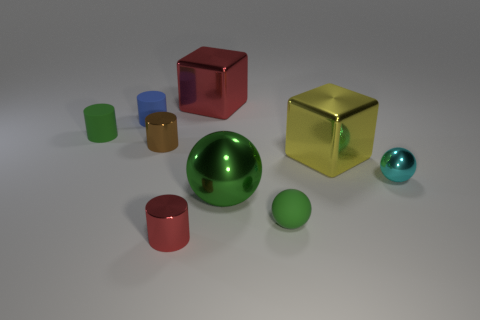Is the rubber sphere the same color as the small metal sphere?
Ensure brevity in your answer.  No. What number of spheres are small brown things or small cyan matte objects?
Offer a terse response. 0. What shape is the tiny green matte object that is in front of the yellow metal object?
Your answer should be very brief. Sphere. How many tiny green objects have the same material as the tiny green ball?
Keep it short and to the point. 1. Are there fewer metallic balls left of the big red metal thing than small rubber objects?
Offer a very short reply. Yes. There is a red block behind the tiny sphere in front of the cyan ball; what is its size?
Provide a succinct answer. Large. Is the color of the tiny metal ball the same as the small cylinder in front of the yellow block?
Offer a very short reply. No. What is the material of the cyan object that is the same size as the blue thing?
Provide a succinct answer. Metal. Are there fewer big objects right of the tiny cyan metal ball than red things that are in front of the green metallic thing?
Offer a very short reply. Yes. There is a red metallic object behind the tiny green matte thing on the left side of the brown metal cylinder; what shape is it?
Your response must be concise. Cube. 